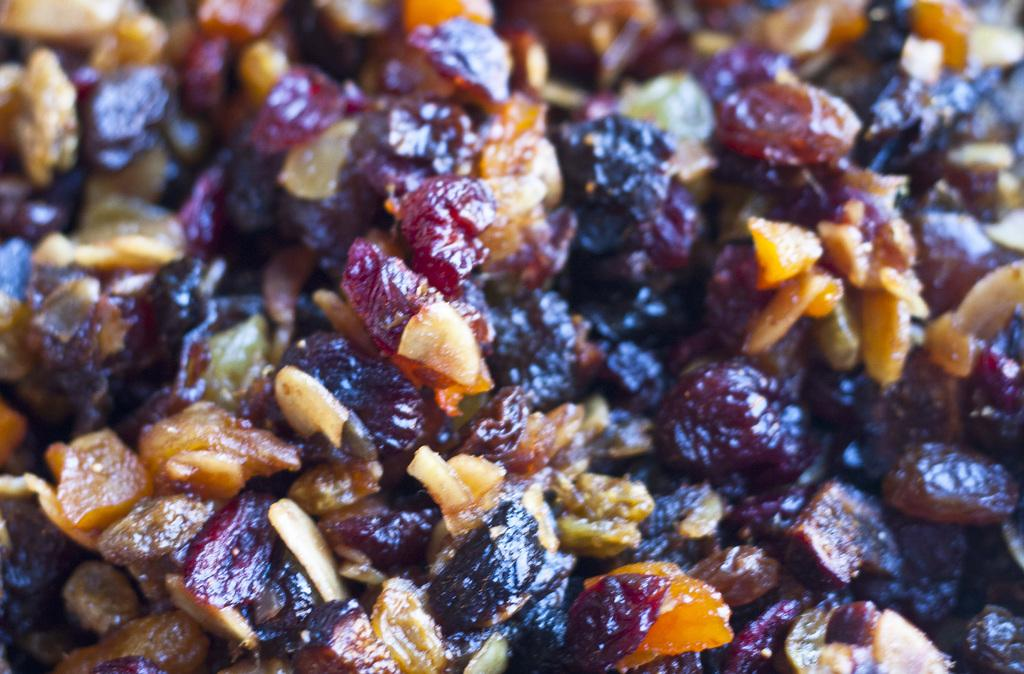What can be seen in the image? There are food items in the image. Can you describe the food items in more detail? Yes, there are ingredients visible on the food. Where is the rabbit sitting on the throne in the image? There is no rabbit or throne present in the image; it only features food items with visible ingredients. 